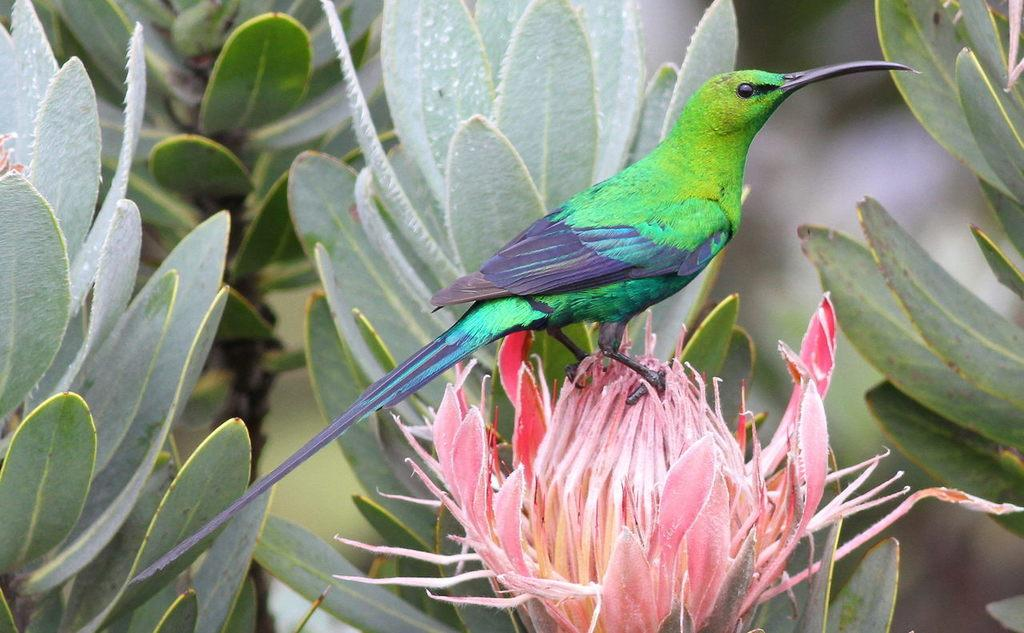What type of animal is in the image? There is a bird in the image. Where is the bird located? The bird is on a flower. What can be seen in the background of the image? There are trees in the background of the image. Is there any snow visible in the image? No, there is no snow present in the image. The image features a bird on a flower with trees in the background, and the weather appears to be clear. 